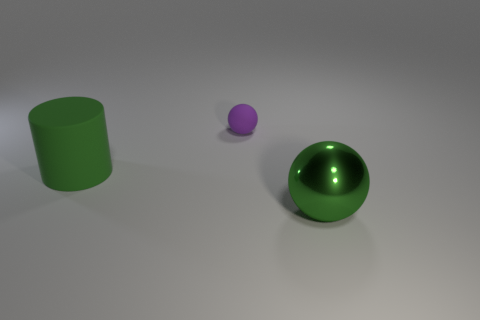Add 3 matte cylinders. How many objects exist? 6 Subtract all purple balls. How many balls are left? 1 Subtract all cylinders. How many objects are left? 2 Subtract 1 balls. How many balls are left? 1 Add 3 big matte things. How many big matte things are left? 4 Add 2 red shiny cylinders. How many red shiny cylinders exist? 2 Subtract 1 green spheres. How many objects are left? 2 Subtract all gray cylinders. Subtract all brown cubes. How many cylinders are left? 1 Subtract all brown cylinders. How many red spheres are left? 0 Subtract all big cyan cylinders. Subtract all big things. How many objects are left? 1 